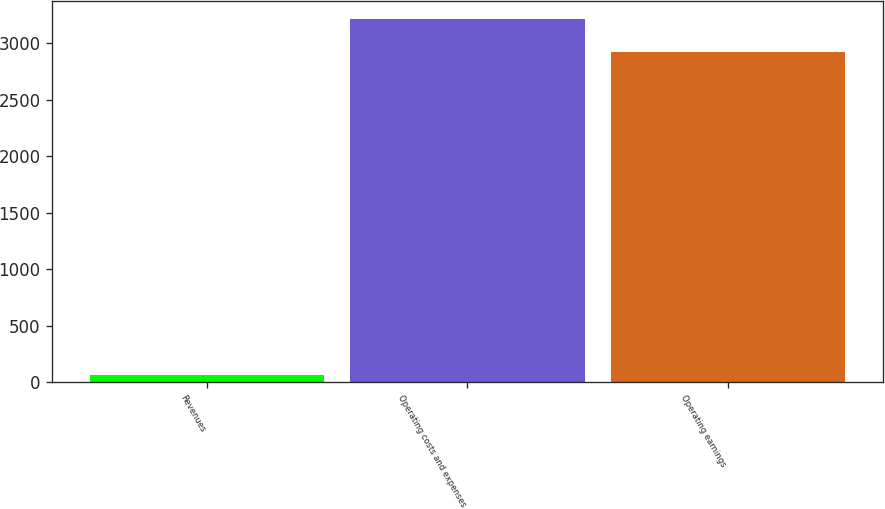Convert chart. <chart><loc_0><loc_0><loc_500><loc_500><bar_chart><fcel>Revenues<fcel>Operating costs and expenses<fcel>Operating earnings<nl><fcel>62<fcel>3216.4<fcel>2924<nl></chart> 